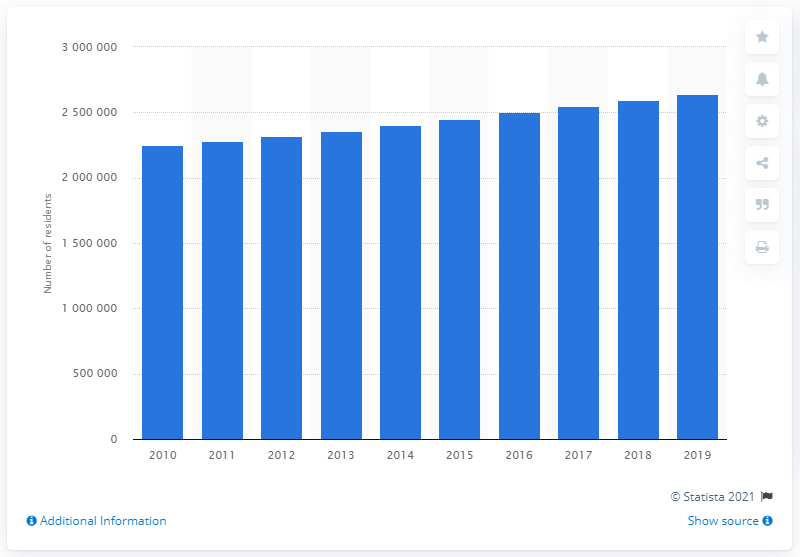Outline some significant characteristics in this image. In the year 2019, the Charlotte-Concord-Gastonia metropolitan area was home to a population of approximately 2,636,883 people. 